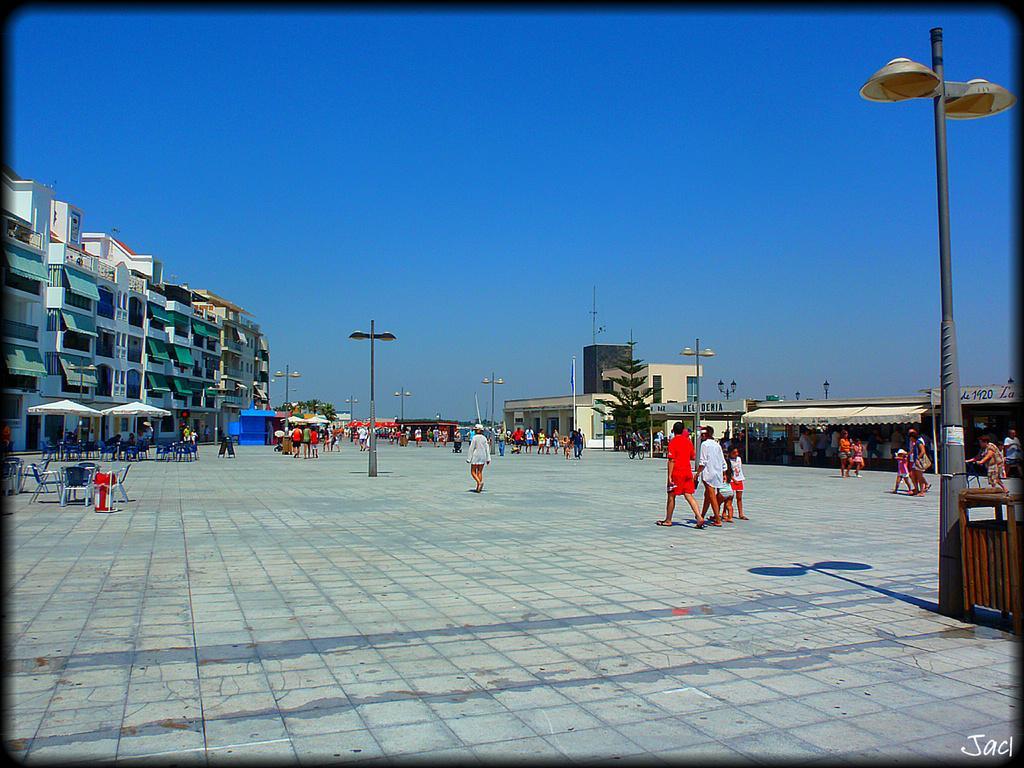How would you summarize this image in a sentence or two? In this image we can see few people walking on the floor, there are few chairs, umbrellas, few light poles, a wooden object near the light pole, there are few buildings, a tree and the sky in the background. 